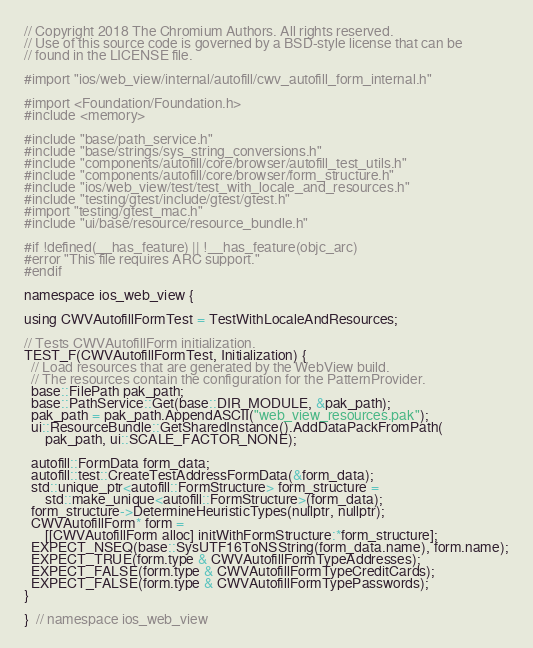<code> <loc_0><loc_0><loc_500><loc_500><_ObjectiveC_>// Copyright 2018 The Chromium Authors. All rights reserved.
// Use of this source code is governed by a BSD-style license that can be
// found in the LICENSE file.

#import "ios/web_view/internal/autofill/cwv_autofill_form_internal.h"

#import <Foundation/Foundation.h>
#include <memory>

#include "base/path_service.h"
#include "base/strings/sys_string_conversions.h"
#include "components/autofill/core/browser/autofill_test_utils.h"
#include "components/autofill/core/browser/form_structure.h"
#include "ios/web_view/test/test_with_locale_and_resources.h"
#include "testing/gtest/include/gtest/gtest.h"
#import "testing/gtest_mac.h"
#include "ui/base/resource/resource_bundle.h"

#if !defined(__has_feature) || !__has_feature(objc_arc)
#error "This file requires ARC support."
#endif

namespace ios_web_view {

using CWVAutofillFormTest = TestWithLocaleAndResources;

// Tests CWVAutofillForm initialization.
TEST_F(CWVAutofillFormTest, Initialization) {
  // Load resources that are generated by the WebView build.
  // The resources contain the configuration for the PatternProvider.
  base::FilePath pak_path;
  base::PathService::Get(base::DIR_MODULE, &pak_path);
  pak_path = pak_path.AppendASCII("web_view_resources.pak");
  ui::ResourceBundle::GetSharedInstance().AddDataPackFromPath(
      pak_path, ui::SCALE_FACTOR_NONE);

  autofill::FormData form_data;
  autofill::test::CreateTestAddressFormData(&form_data);
  std::unique_ptr<autofill::FormStructure> form_structure =
      std::make_unique<autofill::FormStructure>(form_data);
  form_structure->DetermineHeuristicTypes(nullptr, nullptr);
  CWVAutofillForm* form =
      [[CWVAutofillForm alloc] initWithFormStructure:*form_structure];
  EXPECT_NSEQ(base::SysUTF16ToNSString(form_data.name), form.name);
  EXPECT_TRUE(form.type & CWVAutofillFormTypeAddresses);
  EXPECT_FALSE(form.type & CWVAutofillFormTypeCreditCards);
  EXPECT_FALSE(form.type & CWVAutofillFormTypePasswords);
}

}  // namespace ios_web_view
</code> 